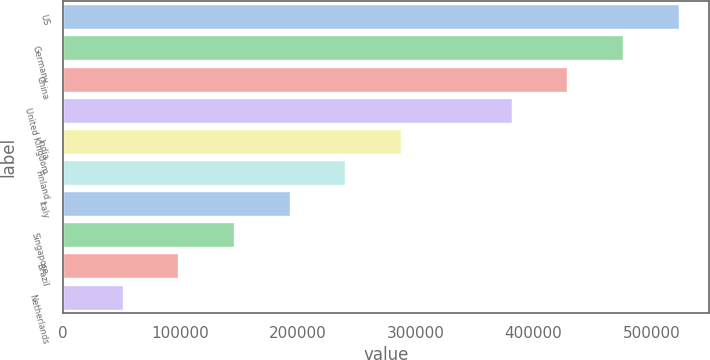<chart> <loc_0><loc_0><loc_500><loc_500><bar_chart><fcel>US<fcel>Germany<fcel>China<fcel>United Kingdom<fcel>India<fcel>Finland<fcel>Italy<fcel>Singapore<fcel>Brazil<fcel>Netherlands<nl><fcel>523262<fcel>476044<fcel>428826<fcel>381609<fcel>287174<fcel>239956<fcel>192739<fcel>145522<fcel>98304<fcel>51086.5<nl></chart> 